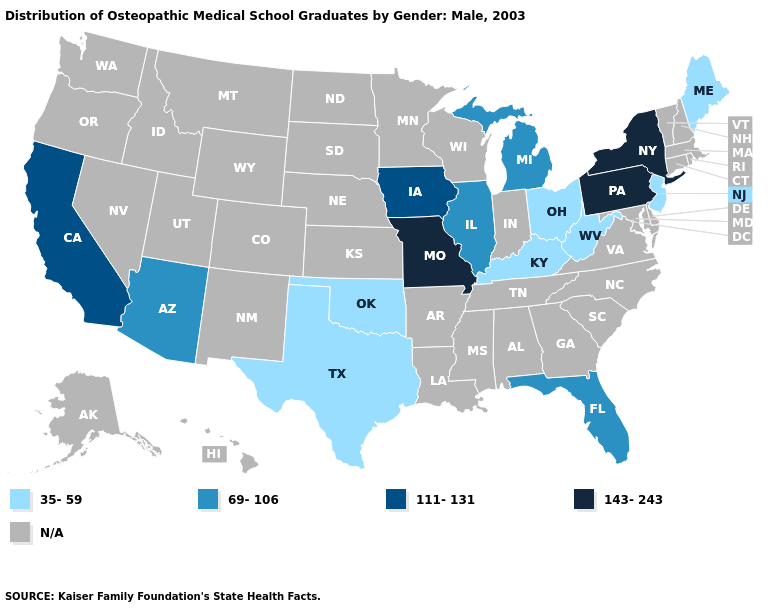What is the value of Kentucky?
Quick response, please. 35-59. Name the states that have a value in the range 143-243?
Keep it brief. Missouri, New York, Pennsylvania. Does Pennsylvania have the highest value in the USA?
Give a very brief answer. Yes. Name the states that have a value in the range N/A?
Give a very brief answer. Alabama, Alaska, Arkansas, Colorado, Connecticut, Delaware, Georgia, Hawaii, Idaho, Indiana, Kansas, Louisiana, Maryland, Massachusetts, Minnesota, Mississippi, Montana, Nebraska, Nevada, New Hampshire, New Mexico, North Carolina, North Dakota, Oregon, Rhode Island, South Carolina, South Dakota, Tennessee, Utah, Vermont, Virginia, Washington, Wisconsin, Wyoming. Does the map have missing data?
Short answer required. Yes. Name the states that have a value in the range 111-131?
Concise answer only. California, Iowa. What is the value of Washington?
Answer briefly. N/A. What is the value of Rhode Island?
Give a very brief answer. N/A. Is the legend a continuous bar?
Concise answer only. No. What is the highest value in the West ?
Concise answer only. 111-131. Name the states that have a value in the range N/A?
Short answer required. Alabama, Alaska, Arkansas, Colorado, Connecticut, Delaware, Georgia, Hawaii, Idaho, Indiana, Kansas, Louisiana, Maryland, Massachusetts, Minnesota, Mississippi, Montana, Nebraska, Nevada, New Hampshire, New Mexico, North Carolina, North Dakota, Oregon, Rhode Island, South Carolina, South Dakota, Tennessee, Utah, Vermont, Virginia, Washington, Wisconsin, Wyoming. What is the highest value in states that border Texas?
Short answer required. 35-59. What is the value of Utah?
Concise answer only. N/A. Name the states that have a value in the range 143-243?
Keep it brief. Missouri, New York, Pennsylvania. 